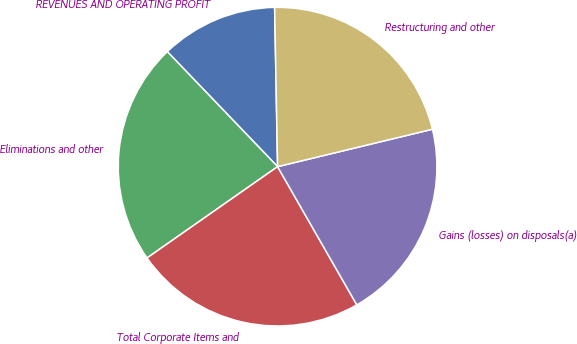Convert chart. <chart><loc_0><loc_0><loc_500><loc_500><pie_chart><fcel>REVENUES AND OPERATING PROFIT<fcel>Eliminations and other<fcel>Total Corporate Items and<fcel>Gains (losses) on disposals(a)<fcel>Restructuring and other<nl><fcel>11.87%<fcel>22.55%<fcel>23.57%<fcel>20.49%<fcel>21.52%<nl></chart> 